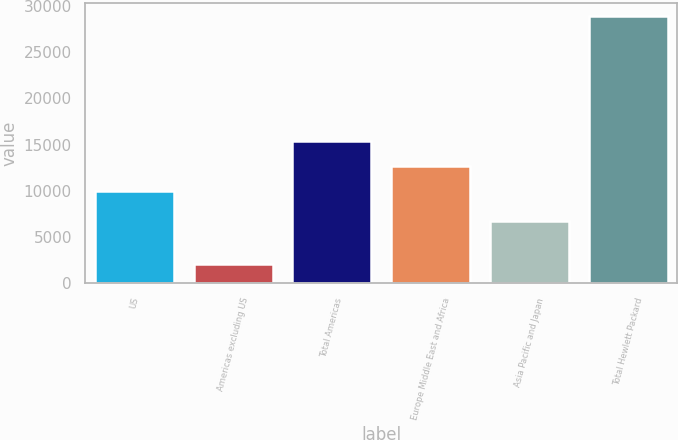<chart> <loc_0><loc_0><loc_500><loc_500><bar_chart><fcel>US<fcel>Americas excluding US<fcel>Total Americas<fcel>Europe Middle East and Africa<fcel>Asia Pacific and Japan<fcel>Total Hewlett Packard<nl><fcel>10022<fcel>2067<fcel>15382.8<fcel>12702.4<fcel>6758<fcel>28871<nl></chart> 